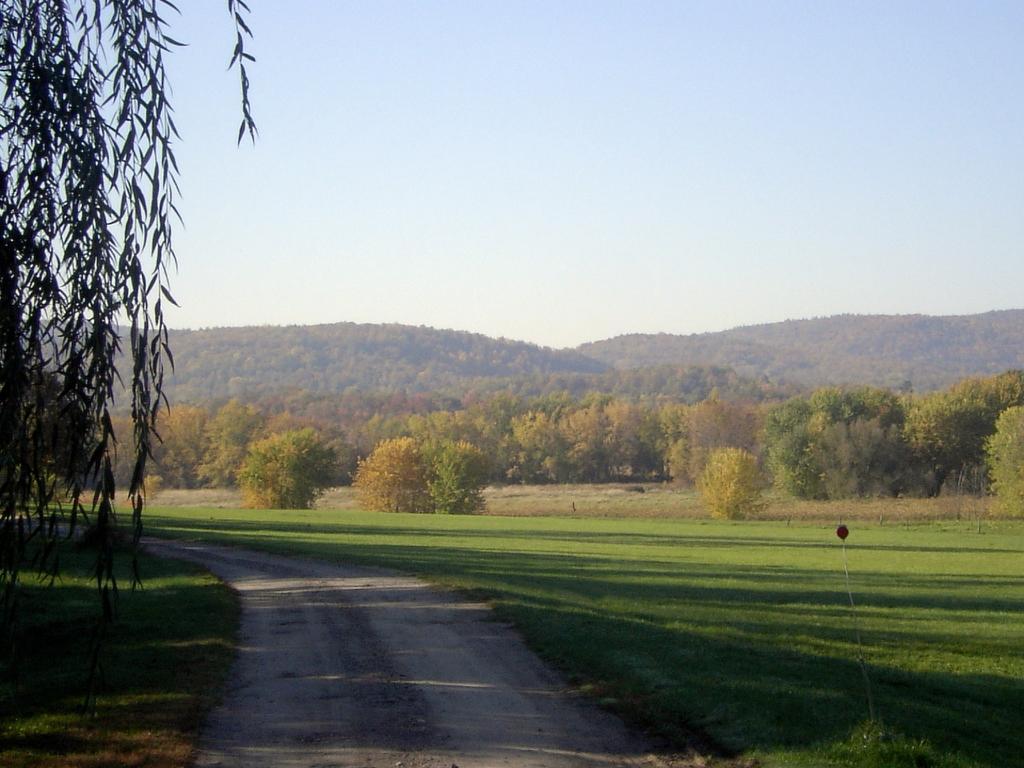Please provide a concise description of this image. This picture is clicked outside. In the foreground we can see the path and the green grass. On the left we can see the leaves. In the background there is a sky, hills, trees and plants. 